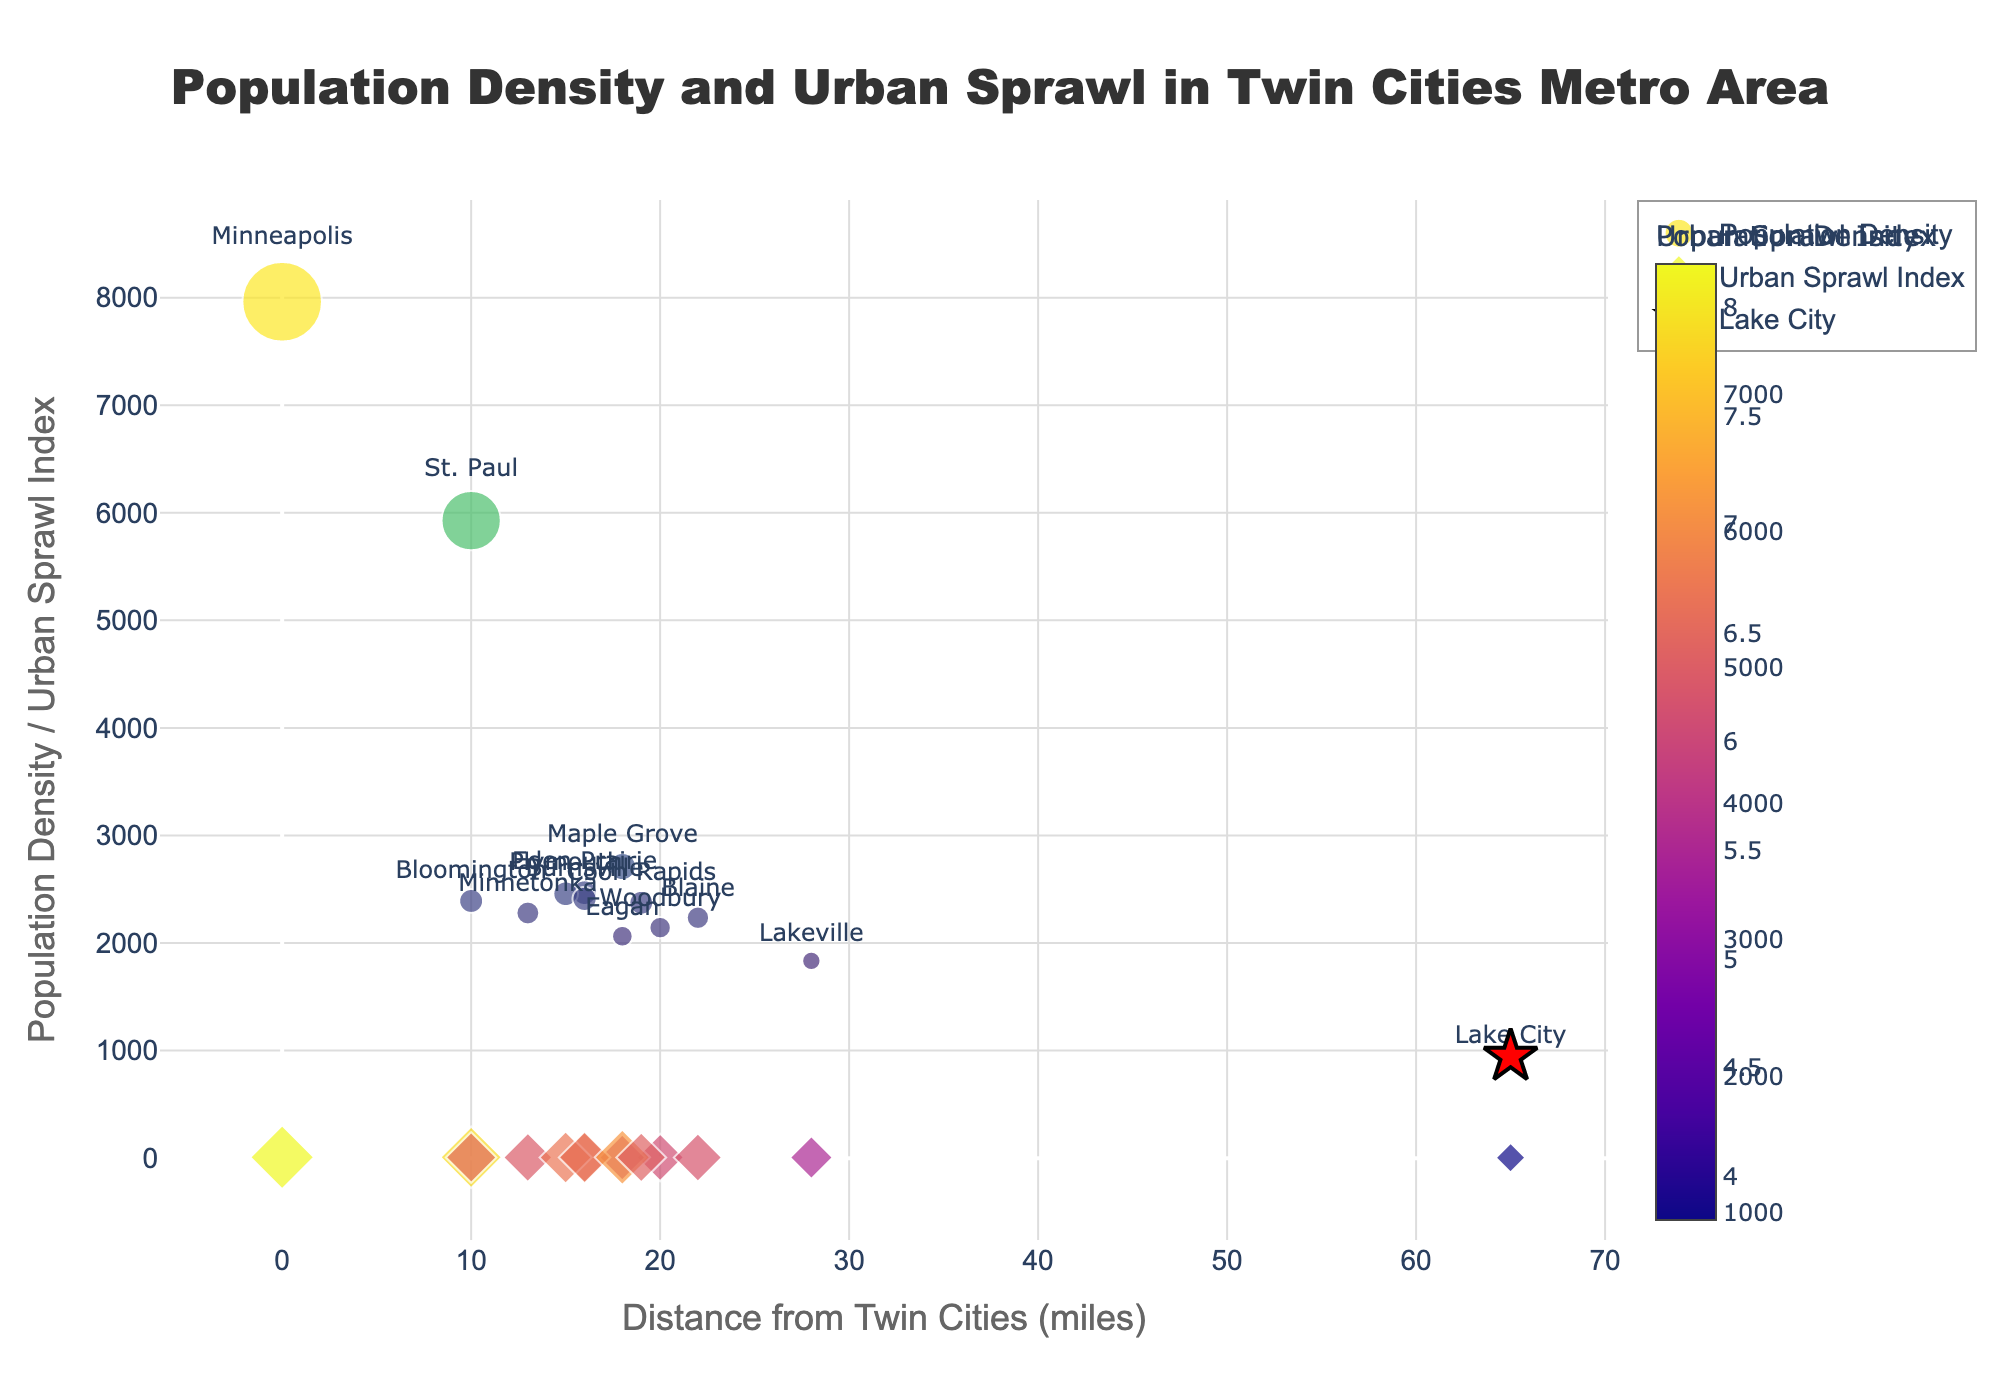How many cities are represented in the plot, and how can you tell? Count the unique markers representing cities based on the 'text' labels provided. There are 14 unique cities mentioned on the y-axis and hover texts.
Answer: 14 What is the population density of Lake City and how is it represented visually? Find "Lake City" marked with a red star, note the population density from the hover text. It's mentioned as a value of 945.
Answer: 945 Which city has the highest Urban Sprawl Index, and what is its value? Look at the markers for Urban Sprawl Index. The city with the highest value has the largest diamond marker. The hover text reveals it is "Minneapolis" with an index of 8.2.
Answer: Minneapolis, 8.2 How does the Population Density of Minneapolis compare to that of Blaine? Find the markers for Minneapolis and Blaine in the Population Density plot, use hover text to get densities and compare. Minneapolis has a density of 7962 while Blaine has 2235, so Minneapolis > Blaine.
Answer: Minneapolis > Blaine What seems to be the relationship between Distance from Twin Cities and Population Density? Visually assess the scatter plot; cities closer to Twin Cities (left side) have higher density markers. As you move to the right (higher distance), marker size generally decreases, indicating a negative correlation.
Answer: Generally negative correlation Which city is closest to the Twin Cities and what is its Population Density? Look for the city with the marker at the 0-mile position on the x-axis. The hover text shows it is "Minneapolis" with a density of 7962.
Answer: Minneapolis, 7962 What is the clear trend visible between the Urban Sprawl Index and the Distance from Twin Cities? Observe the diamond markers for Urban Sprawl Index. As the distance increases (right), the size of the diamonds generally decreases, indicating sprawl decreases with distance.
Answer: Decreases with distance What's the average Urban Sprawl Index for cities more than 20 miles from the Twin Cities? Calculate the average for Blaine (6.2), Woodbury (6.1), and Lake City (3.8). (6.2 + 6.1 + 3.8)/3 = 5.37.
Answer: 5.37 Which has a higher population density: Maple Grove or Eagan, and how can you tell? Compare Maple Grove and Eagan's markers in the Population Density plot. Hover texts show Maple Grove (2711) is denser than Eagan (2063).
Answer: Maple Grove Is there a city that has similar values for both Population Density and Urban Sprawl Index? If yes, name it. Compare both plots visually to spot cities with similar-sized markers. Coon Rapids has density 2374 and sprawl 6.4, closely aligning in terms of marker size.
Answer: Coon Rapids 